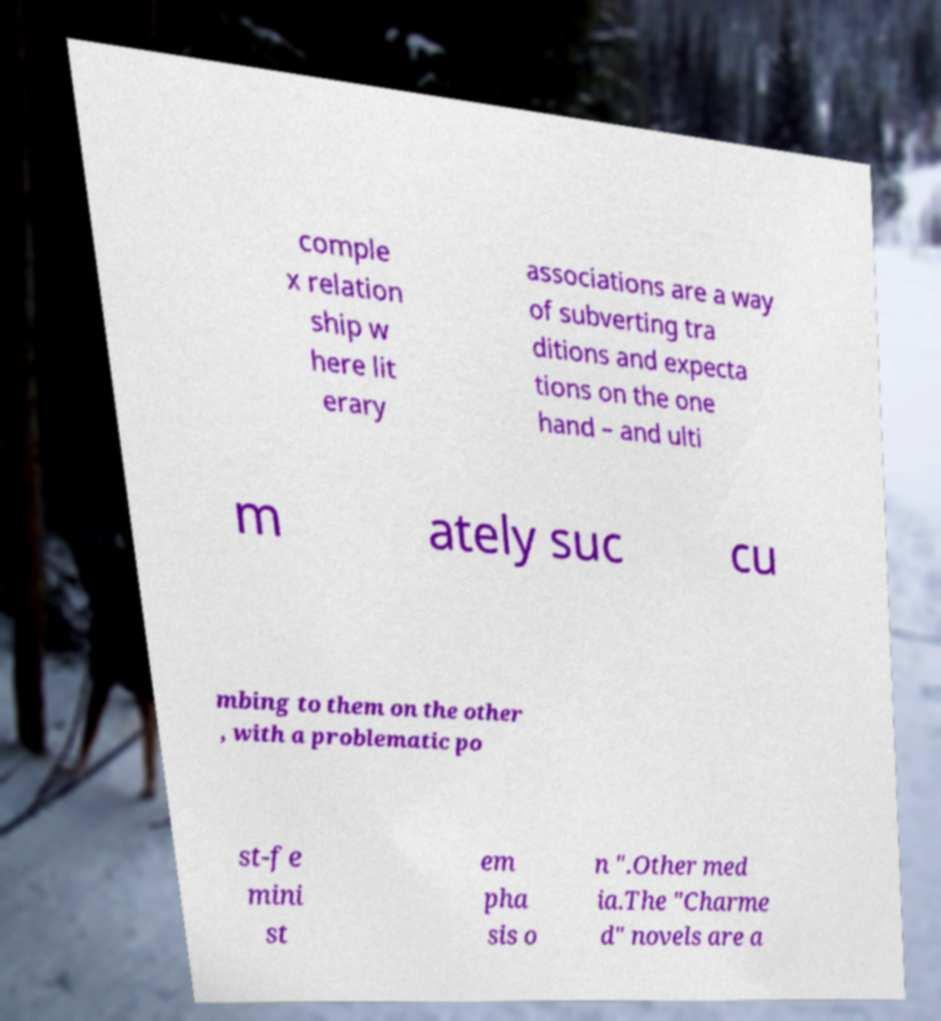Could you assist in decoding the text presented in this image and type it out clearly? comple x relation ship w here lit erary associations are a way of subverting tra ditions and expecta tions on the one hand – and ulti m ately suc cu mbing to them on the other , with a problematic po st-fe mini st em pha sis o n ".Other med ia.The "Charme d" novels are a 